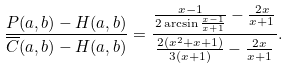Convert formula to latex. <formula><loc_0><loc_0><loc_500><loc_500>\frac { P ( a , b ) - H ( a , b ) } { \overline { C } ( a , b ) - H ( a , b ) } = \frac { \frac { x - 1 } { 2 \arcsin \frac { x - 1 } { x + 1 } } - \frac { 2 x } { x + 1 } } { \frac { 2 ( x ^ { 2 } + x + 1 ) } { 3 ( x + 1 ) } - \frac { 2 x } { x + 1 } } .</formula> 